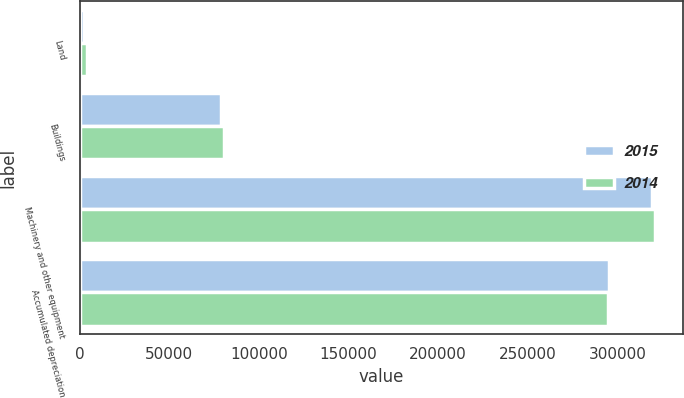<chart> <loc_0><loc_0><loc_500><loc_500><stacked_bar_chart><ecel><fcel>Land<fcel>Buildings<fcel>Machinery and other equipment<fcel>Accumulated depreciation<nl><fcel>2015<fcel>2488<fcel>79182<fcel>319416<fcel>295576<nl><fcel>2014<fcel>4130<fcel>80775<fcel>320697<fcel>294726<nl></chart> 